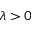Convert formula to latex. <formula><loc_0><loc_0><loc_500><loc_500>\lambda > 0</formula> 